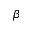Convert formula to latex. <formula><loc_0><loc_0><loc_500><loc_500>\beta</formula> 